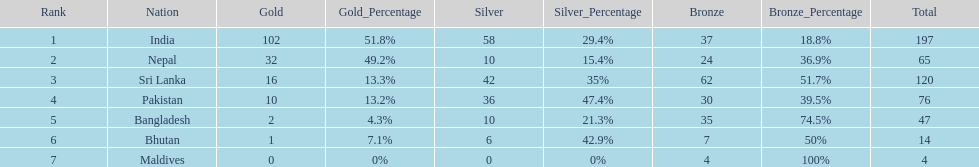Which nation has earned the least amount of gold medals? Maldives. 